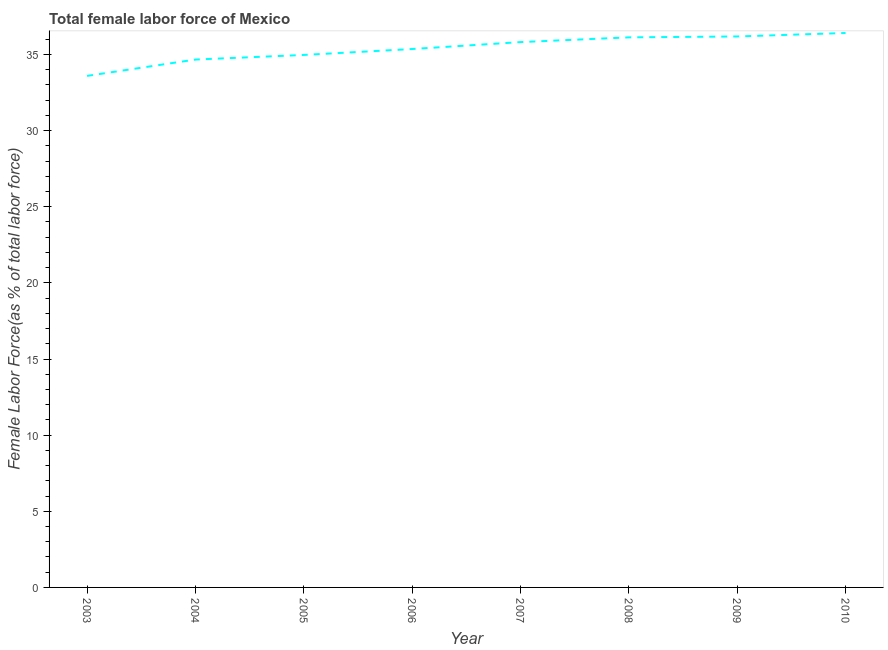What is the total female labor force in 2006?
Your answer should be very brief. 35.36. Across all years, what is the maximum total female labor force?
Your answer should be compact. 36.41. Across all years, what is the minimum total female labor force?
Ensure brevity in your answer.  33.59. In which year was the total female labor force maximum?
Provide a short and direct response. 2010. In which year was the total female labor force minimum?
Offer a terse response. 2003. What is the sum of the total female labor force?
Your answer should be very brief. 283.13. What is the difference between the total female labor force in 2003 and 2009?
Your response must be concise. -2.59. What is the average total female labor force per year?
Make the answer very short. 35.39. What is the median total female labor force?
Provide a short and direct response. 35.59. In how many years, is the total female labor force greater than 3 %?
Your response must be concise. 8. What is the ratio of the total female labor force in 2003 to that in 2005?
Offer a very short reply. 0.96. Is the difference between the total female labor force in 2009 and 2010 greater than the difference between any two years?
Offer a terse response. No. What is the difference between the highest and the second highest total female labor force?
Provide a short and direct response. 0.23. Is the sum of the total female labor force in 2003 and 2005 greater than the maximum total female labor force across all years?
Provide a succinct answer. Yes. What is the difference between the highest and the lowest total female labor force?
Your answer should be very brief. 2.82. Does the total female labor force monotonically increase over the years?
Keep it short and to the point. Yes. How many years are there in the graph?
Give a very brief answer. 8. What is the title of the graph?
Your response must be concise. Total female labor force of Mexico. What is the label or title of the X-axis?
Make the answer very short. Year. What is the label or title of the Y-axis?
Ensure brevity in your answer.  Female Labor Force(as % of total labor force). What is the Female Labor Force(as % of total labor force) of 2003?
Offer a terse response. 33.59. What is the Female Labor Force(as % of total labor force) in 2004?
Provide a succinct answer. 34.67. What is the Female Labor Force(as % of total labor force) of 2005?
Your response must be concise. 34.97. What is the Female Labor Force(as % of total labor force) of 2006?
Make the answer very short. 35.36. What is the Female Labor Force(as % of total labor force) of 2007?
Provide a succinct answer. 35.81. What is the Female Labor Force(as % of total labor force) of 2008?
Offer a very short reply. 36.13. What is the Female Labor Force(as % of total labor force) in 2009?
Provide a succinct answer. 36.18. What is the Female Labor Force(as % of total labor force) of 2010?
Offer a terse response. 36.41. What is the difference between the Female Labor Force(as % of total labor force) in 2003 and 2004?
Your response must be concise. -1.07. What is the difference between the Female Labor Force(as % of total labor force) in 2003 and 2005?
Provide a succinct answer. -1.38. What is the difference between the Female Labor Force(as % of total labor force) in 2003 and 2006?
Your answer should be compact. -1.76. What is the difference between the Female Labor Force(as % of total labor force) in 2003 and 2007?
Your answer should be very brief. -2.22. What is the difference between the Female Labor Force(as % of total labor force) in 2003 and 2008?
Your answer should be compact. -2.53. What is the difference between the Female Labor Force(as % of total labor force) in 2003 and 2009?
Keep it short and to the point. -2.59. What is the difference between the Female Labor Force(as % of total labor force) in 2003 and 2010?
Offer a very short reply. -2.82. What is the difference between the Female Labor Force(as % of total labor force) in 2004 and 2005?
Ensure brevity in your answer.  -0.3. What is the difference between the Female Labor Force(as % of total labor force) in 2004 and 2006?
Provide a short and direct response. -0.69. What is the difference between the Female Labor Force(as % of total labor force) in 2004 and 2007?
Make the answer very short. -1.15. What is the difference between the Female Labor Force(as % of total labor force) in 2004 and 2008?
Offer a terse response. -1.46. What is the difference between the Female Labor Force(as % of total labor force) in 2004 and 2009?
Offer a terse response. -1.52. What is the difference between the Female Labor Force(as % of total labor force) in 2004 and 2010?
Your answer should be compact. -1.75. What is the difference between the Female Labor Force(as % of total labor force) in 2005 and 2006?
Your answer should be very brief. -0.39. What is the difference between the Female Labor Force(as % of total labor force) in 2005 and 2007?
Your answer should be very brief. -0.84. What is the difference between the Female Labor Force(as % of total labor force) in 2005 and 2008?
Provide a short and direct response. -1.15. What is the difference between the Female Labor Force(as % of total labor force) in 2005 and 2009?
Ensure brevity in your answer.  -1.21. What is the difference between the Female Labor Force(as % of total labor force) in 2005 and 2010?
Offer a very short reply. -1.44. What is the difference between the Female Labor Force(as % of total labor force) in 2006 and 2007?
Provide a succinct answer. -0.45. What is the difference between the Female Labor Force(as % of total labor force) in 2006 and 2008?
Provide a succinct answer. -0.77. What is the difference between the Female Labor Force(as % of total labor force) in 2006 and 2009?
Give a very brief answer. -0.82. What is the difference between the Female Labor Force(as % of total labor force) in 2006 and 2010?
Offer a terse response. -1.05. What is the difference between the Female Labor Force(as % of total labor force) in 2007 and 2008?
Keep it short and to the point. -0.31. What is the difference between the Female Labor Force(as % of total labor force) in 2007 and 2009?
Your response must be concise. -0.37. What is the difference between the Female Labor Force(as % of total labor force) in 2007 and 2010?
Provide a short and direct response. -0.6. What is the difference between the Female Labor Force(as % of total labor force) in 2008 and 2009?
Offer a terse response. -0.06. What is the difference between the Female Labor Force(as % of total labor force) in 2008 and 2010?
Offer a very short reply. -0.29. What is the difference between the Female Labor Force(as % of total labor force) in 2009 and 2010?
Your response must be concise. -0.23. What is the ratio of the Female Labor Force(as % of total labor force) in 2003 to that in 2004?
Your response must be concise. 0.97. What is the ratio of the Female Labor Force(as % of total labor force) in 2003 to that in 2007?
Offer a terse response. 0.94. What is the ratio of the Female Labor Force(as % of total labor force) in 2003 to that in 2008?
Provide a short and direct response. 0.93. What is the ratio of the Female Labor Force(as % of total labor force) in 2003 to that in 2009?
Your answer should be compact. 0.93. What is the ratio of the Female Labor Force(as % of total labor force) in 2003 to that in 2010?
Make the answer very short. 0.92. What is the ratio of the Female Labor Force(as % of total labor force) in 2004 to that in 2005?
Your answer should be very brief. 0.99. What is the ratio of the Female Labor Force(as % of total labor force) in 2004 to that in 2006?
Your response must be concise. 0.98. What is the ratio of the Female Labor Force(as % of total labor force) in 2004 to that in 2007?
Provide a short and direct response. 0.97. What is the ratio of the Female Labor Force(as % of total labor force) in 2004 to that in 2008?
Make the answer very short. 0.96. What is the ratio of the Female Labor Force(as % of total labor force) in 2004 to that in 2009?
Keep it short and to the point. 0.96. What is the ratio of the Female Labor Force(as % of total labor force) in 2004 to that in 2010?
Ensure brevity in your answer.  0.95. What is the ratio of the Female Labor Force(as % of total labor force) in 2005 to that in 2006?
Keep it short and to the point. 0.99. What is the ratio of the Female Labor Force(as % of total labor force) in 2005 to that in 2008?
Keep it short and to the point. 0.97. What is the ratio of the Female Labor Force(as % of total labor force) in 2006 to that in 2009?
Provide a succinct answer. 0.98. What is the ratio of the Female Labor Force(as % of total labor force) in 2006 to that in 2010?
Provide a short and direct response. 0.97. What is the ratio of the Female Labor Force(as % of total labor force) in 2007 to that in 2008?
Make the answer very short. 0.99. What is the ratio of the Female Labor Force(as % of total labor force) in 2008 to that in 2010?
Ensure brevity in your answer.  0.99. What is the ratio of the Female Labor Force(as % of total labor force) in 2009 to that in 2010?
Your response must be concise. 0.99. 